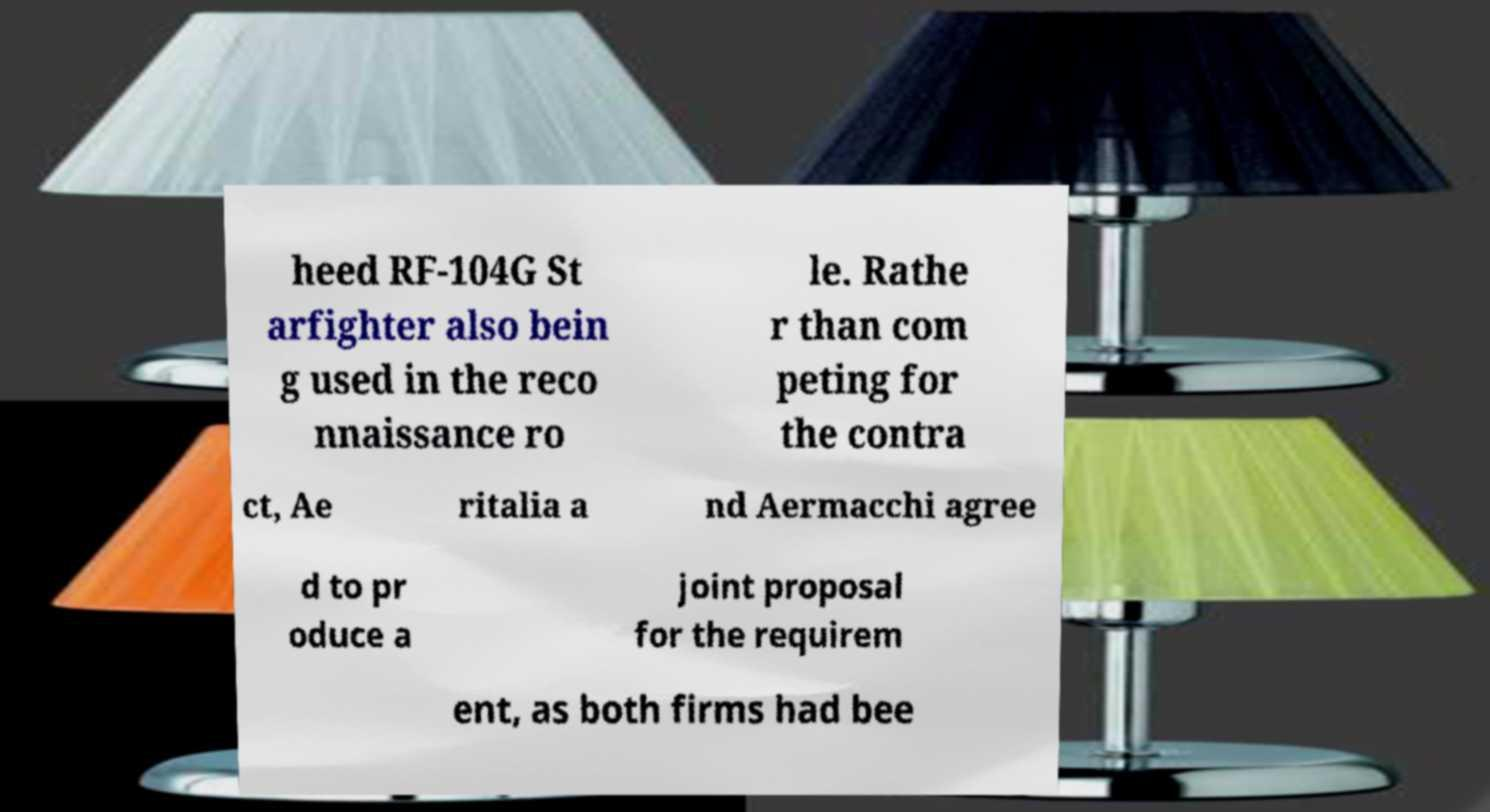What messages or text are displayed in this image? I need them in a readable, typed format. heed RF-104G St arfighter also bein g used in the reco nnaissance ro le. Rathe r than com peting for the contra ct, Ae ritalia a nd Aermacchi agree d to pr oduce a joint proposal for the requirem ent, as both firms had bee 